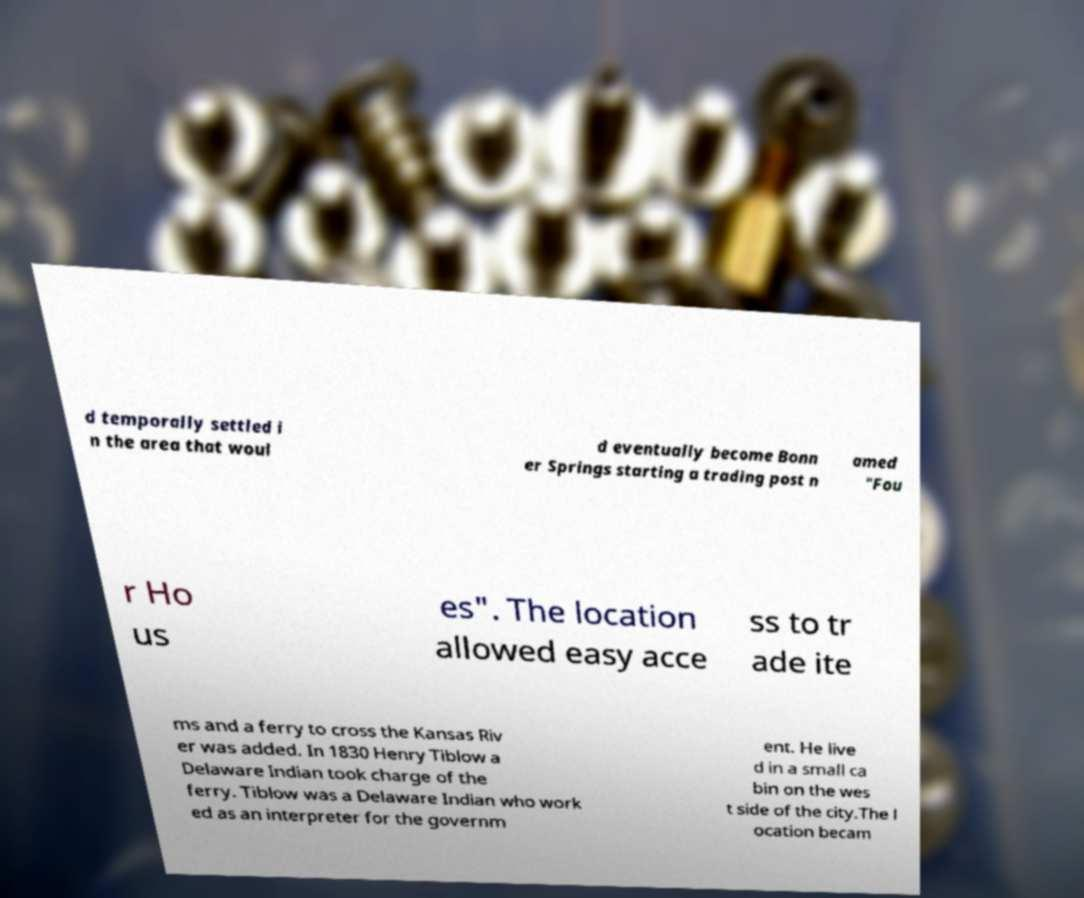I need the written content from this picture converted into text. Can you do that? d temporally settled i n the area that woul d eventually become Bonn er Springs starting a trading post n amed "Fou r Ho us es". The location allowed easy acce ss to tr ade ite ms and a ferry to cross the Kansas Riv er was added. In 1830 Henry Tiblow a Delaware Indian took charge of the ferry. Tiblow was a Delaware Indian who work ed as an interpreter for the governm ent. He live d in a small ca bin on the wes t side of the city.The l ocation becam 